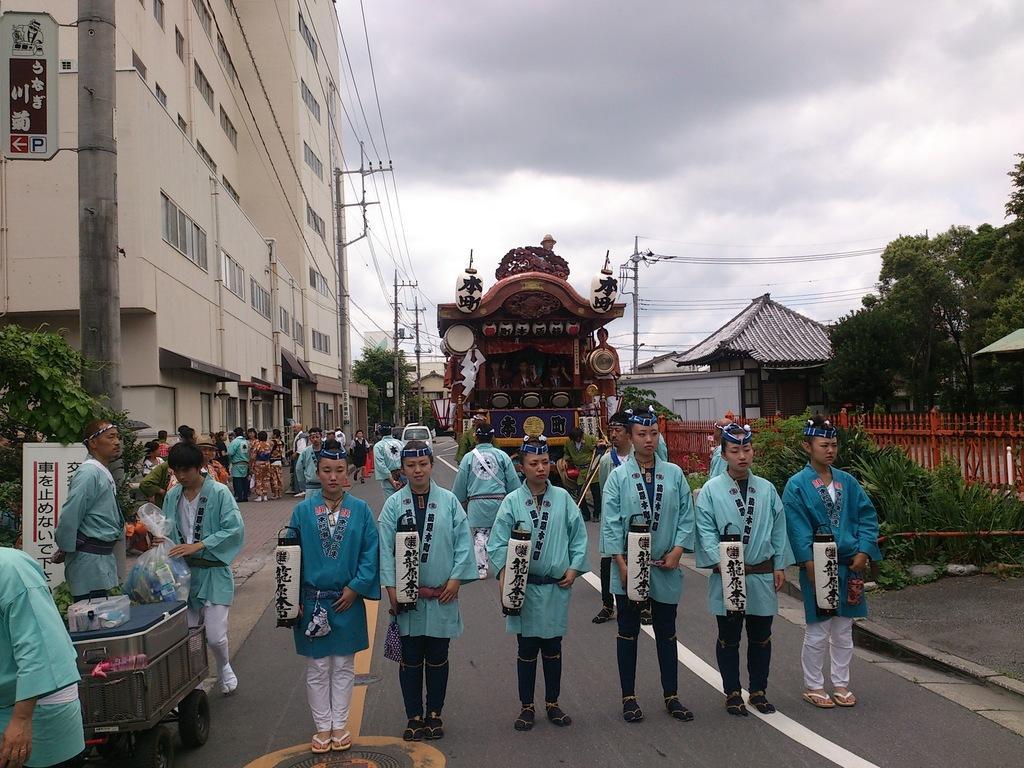In one or two sentences, can you explain what this image depicts? In this picture I can see there are a group of people standing on the road and the person on to left is wearing a dark blue shirt and the person on to right is also wearing a dark blue shirt and the people at the center are wearing light blue shirts. In the backdrop there are few vehicles and plants on to left, there are buildings on to left and right and there are trees and the sky is clear. In the backdrop there are a group of people standing on the walk way. 